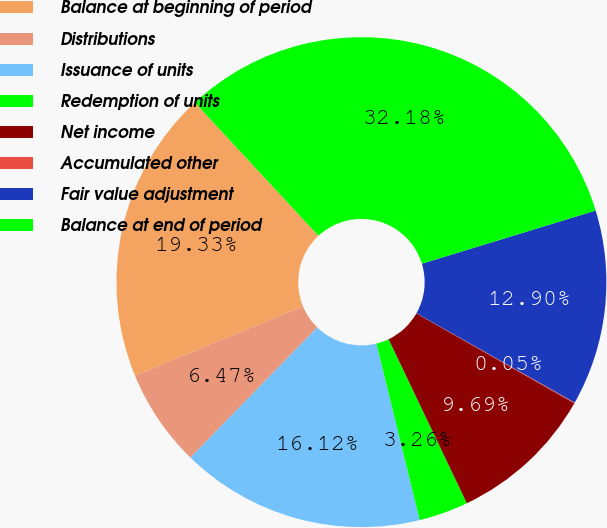Convert chart to OTSL. <chart><loc_0><loc_0><loc_500><loc_500><pie_chart><fcel>Balance at beginning of period<fcel>Distributions<fcel>Issuance of units<fcel>Redemption of units<fcel>Net income<fcel>Accumulated other<fcel>Fair value adjustment<fcel>Balance at end of period<nl><fcel>19.33%<fcel>6.47%<fcel>16.12%<fcel>3.26%<fcel>9.69%<fcel>0.05%<fcel>12.9%<fcel>32.18%<nl></chart> 